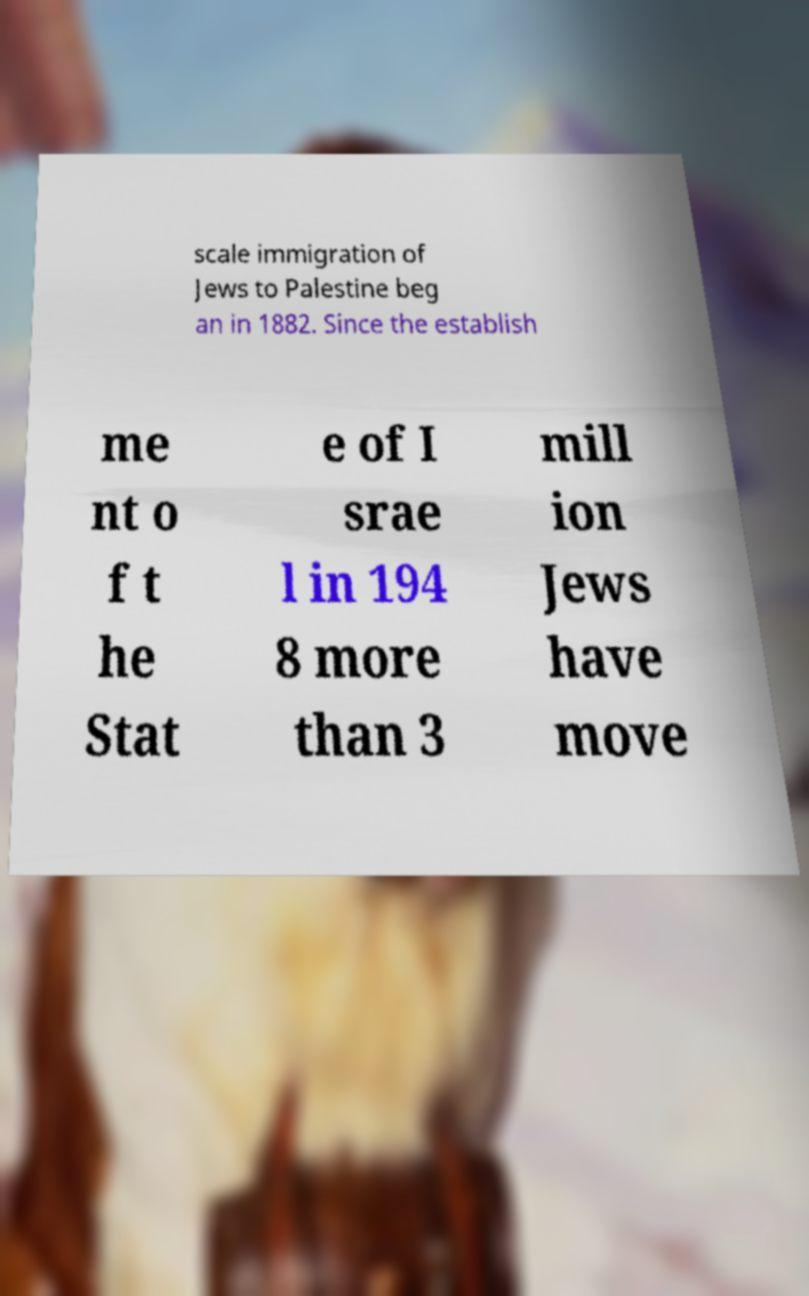I need the written content from this picture converted into text. Can you do that? scale immigration of Jews to Palestine beg an in 1882. Since the establish me nt o f t he Stat e of I srae l in 194 8 more than 3 mill ion Jews have move 